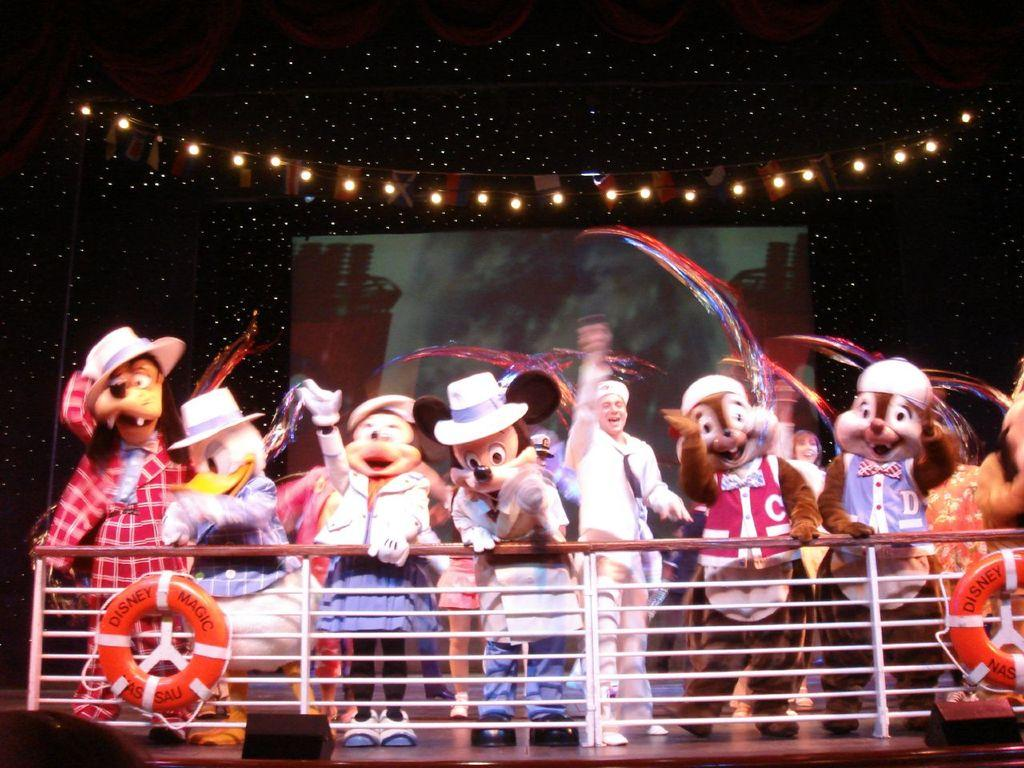What are the people in the image wearing? The people in the image are wearing different costumes. Where are the people standing in the image? The people are standing on the floor. What can be seen near the people in the image? There is railing visible in the image. What else is present in the background of the image? There are tubes, a screen, and lights in the background of the image. There is also a banner in the background. Can you see any grass growing in the image? There is no grass visible in the image; the image features people in costumes, railing, tubes, a screen, lights, and a banner. 